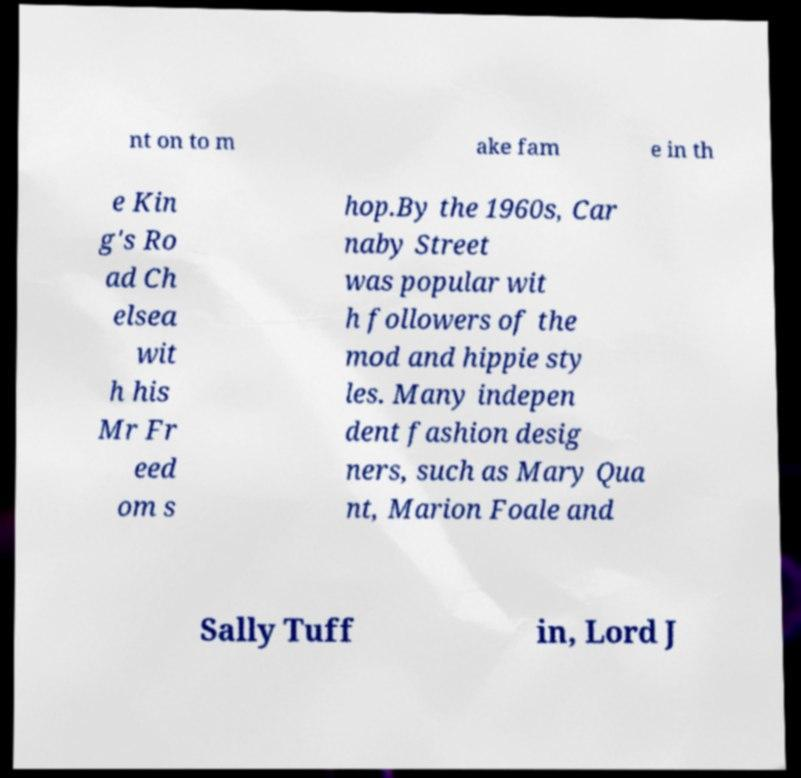Please read and relay the text visible in this image. What does it say? nt on to m ake fam e in th e Kin g's Ro ad Ch elsea wit h his Mr Fr eed om s hop.By the 1960s, Car naby Street was popular wit h followers of the mod and hippie sty les. Many indepen dent fashion desig ners, such as Mary Qua nt, Marion Foale and Sally Tuff in, Lord J 